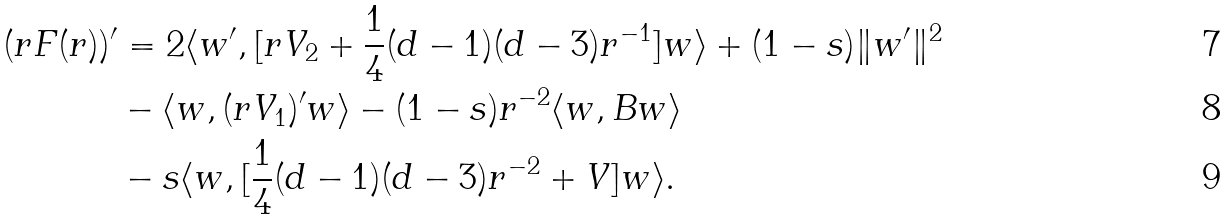Convert formula to latex. <formula><loc_0><loc_0><loc_500><loc_500>( r F ( r ) ) ^ { \prime } & = 2 \langle w ^ { \prime } , [ r V _ { 2 } + \frac { 1 } { 4 } ( d - 1 ) ( d - 3 ) r ^ { - 1 } ] w \rangle + ( 1 - s ) \| w ^ { \prime } \| ^ { 2 } \\ & - \langle w , ( r V _ { 1 } ) ^ { \prime } w \rangle - ( 1 - s ) r ^ { - 2 } \langle w , B w \rangle \\ & - s \langle w , [ \frac { 1 } { 4 } ( d - 1 ) ( d - 3 ) r ^ { - 2 } + V ] w \rangle .</formula> 